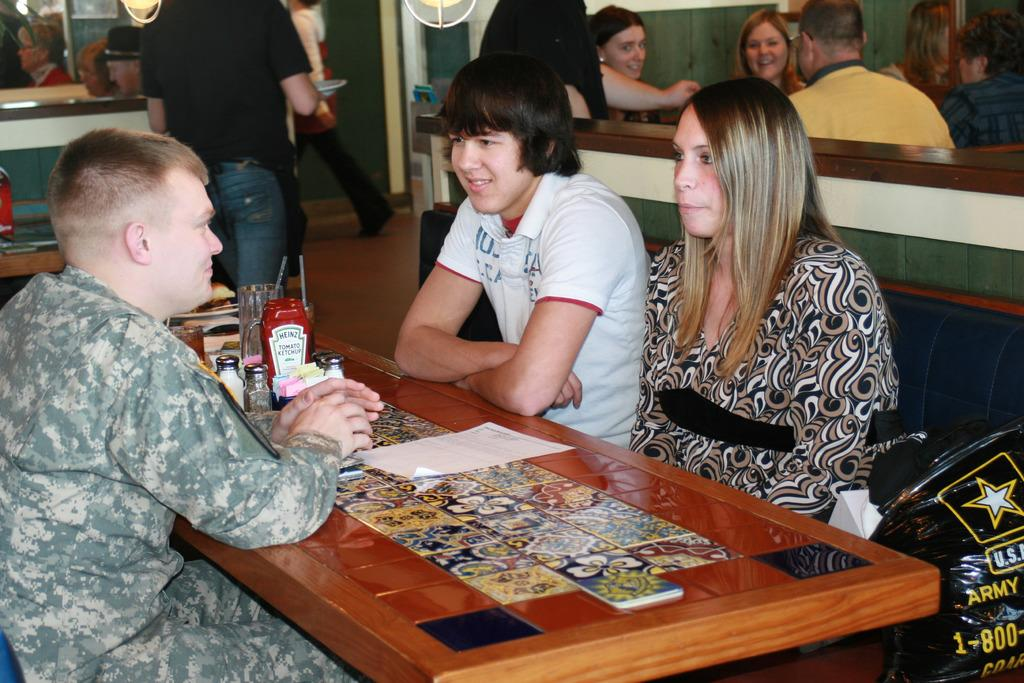What are the people in the image doing? There is a group of people sitting on a couch in the image. What can be seen on the table in the image? There is a stand, a glass, and a paper on the table in the image. What type of letter is the person wearing on their trousers in the image? There are no trousers or letters present in the image. 